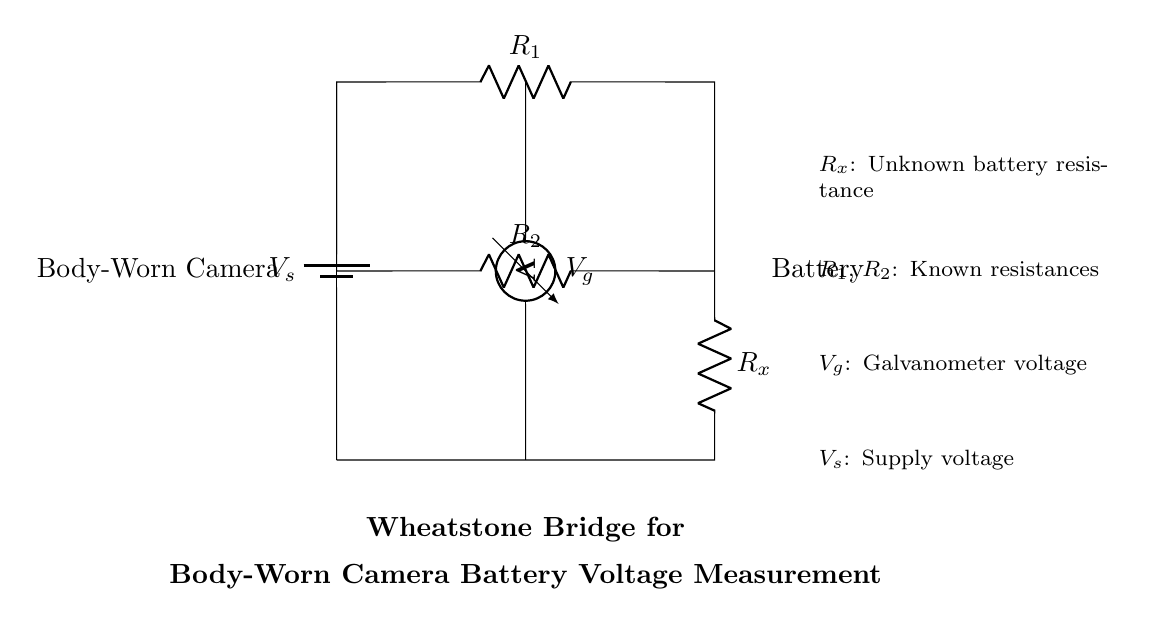What is the voltage source in this circuit? The voltage source is labeled as V_s in the diagram, which provides the electrical energy necessary for the operation of the Wheatstone bridge circuit.
Answer: V_s What component measures the battery voltage? The galvanometer, indicated as V_g in the circuit diagram, is responsible for measuring the voltage across the legs of the Wheatstone bridge.
Answer: V_g What are the known resistances in this Wheatstone bridge? The resistances labeled R_1 and R_2 in the circuit are the known resistances used to balance the Wheatstone bridge and facilitate precise measurements.
Answer: R_1, R_2 What does R_x represent in the circuit? R_x is designated as the unknown battery resistance, which is the resistance of the body-worn camera's battery that needs to be measured using this bridge setup.
Answer: R_x If the bridge is balanced, what is the condition for V_g? When the Wheatstone bridge is balanced, V_g should be zero volts, indicating that the voltage drop across both sides of the bridge is equal, leading to no current through the galvanometer.
Answer: 0 volts What does a zero reading on the galvanometer indicate? A zero reading on the galvanometer signifies that the bridge is in a balanced state, meaning that the ratios of the known and unknown resistances are equal, which allows for accurate voltage measurement.
Answer: Balanced state What is the purpose of a Wheatstone bridge in this application? The Wheatstone bridge is designed for precise measurement of the body-worn camera battery voltage by comparing the unknown resistance with known resistances while minimizing measurement errors.
Answer: Precise voltage measurement 